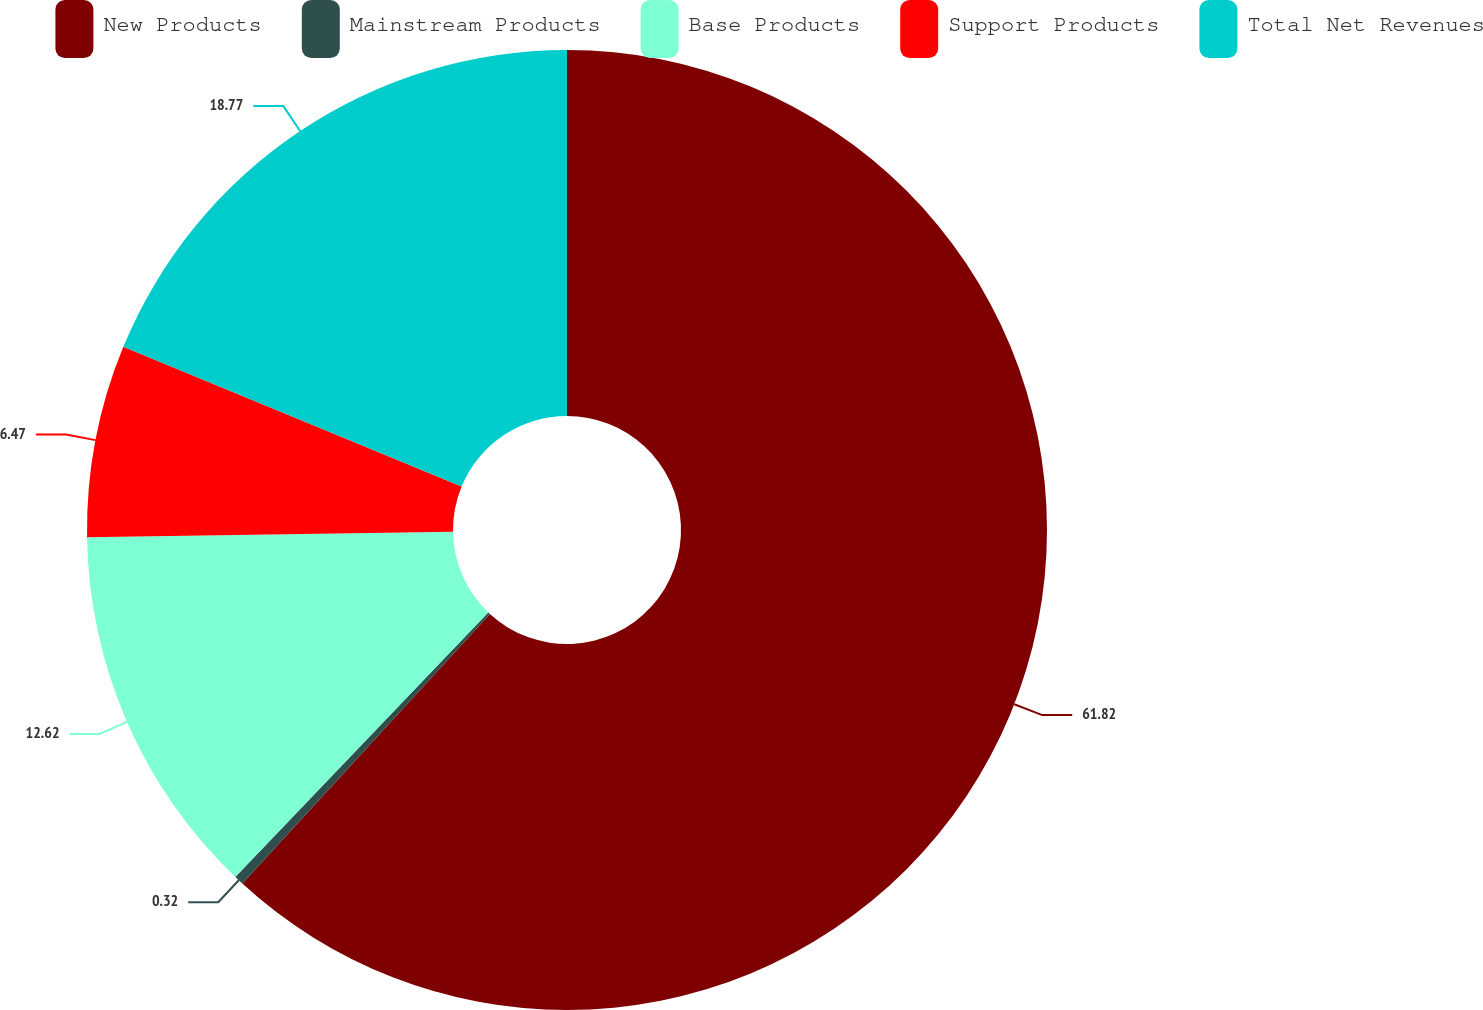Convert chart to OTSL. <chart><loc_0><loc_0><loc_500><loc_500><pie_chart><fcel>New Products<fcel>Mainstream Products<fcel>Base Products<fcel>Support Products<fcel>Total Net Revenues<nl><fcel>61.83%<fcel>0.32%<fcel>12.62%<fcel>6.47%<fcel>18.77%<nl></chart> 